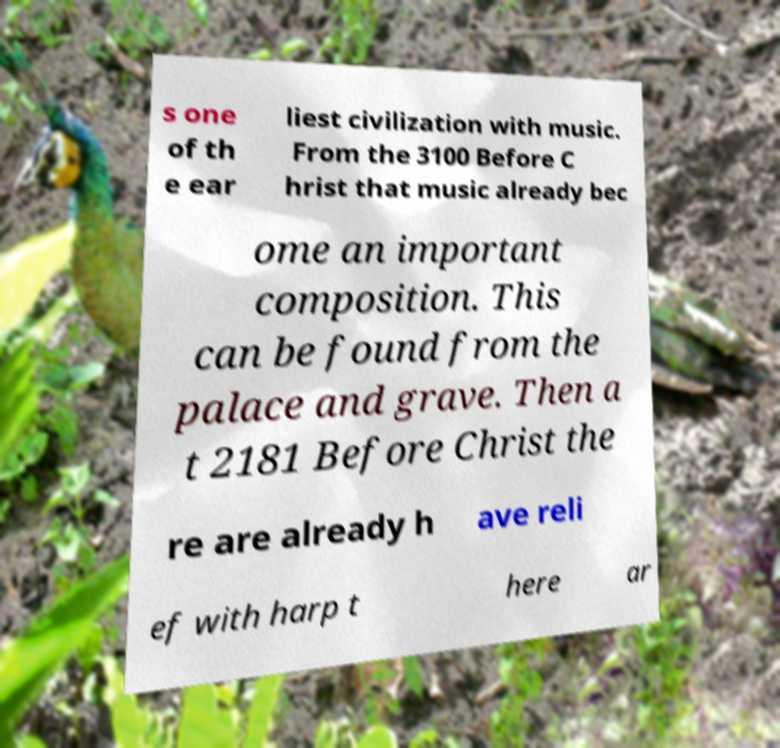For documentation purposes, I need the text within this image transcribed. Could you provide that? s one of th e ear liest civilization with music. From the 3100 Before C hrist that music already bec ome an important composition. This can be found from the palace and grave. Then a t 2181 Before Christ the re are already h ave reli ef with harp t here ar 